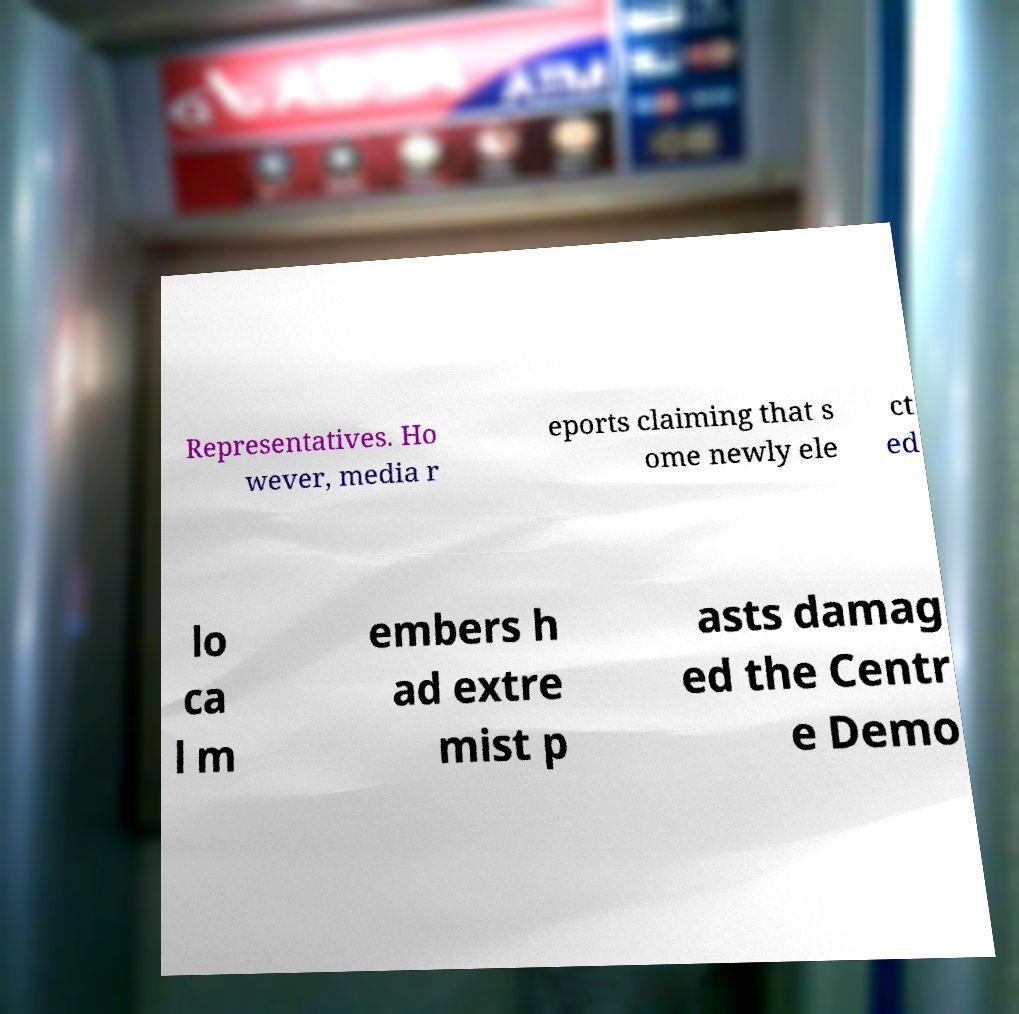There's text embedded in this image that I need extracted. Can you transcribe it verbatim? Representatives. Ho wever, media r eports claiming that s ome newly ele ct ed lo ca l m embers h ad extre mist p asts damag ed the Centr e Demo 